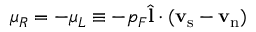<formula> <loc_0><loc_0><loc_500><loc_500>\mu _ { R } = - \mu _ { L } \equiv - p _ { F } { \hat { l } } \cdot ( { v } _ { s } - { v } _ { n } )</formula> 